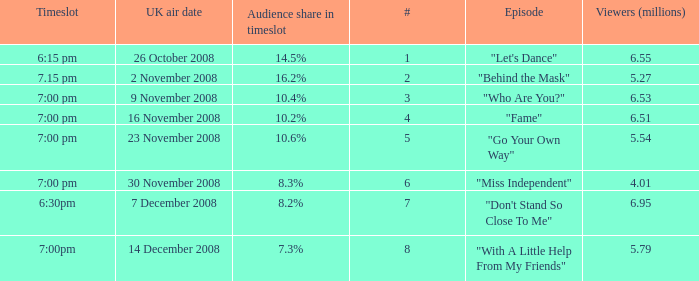Name the most number for viewers being 6.95 7.0. 